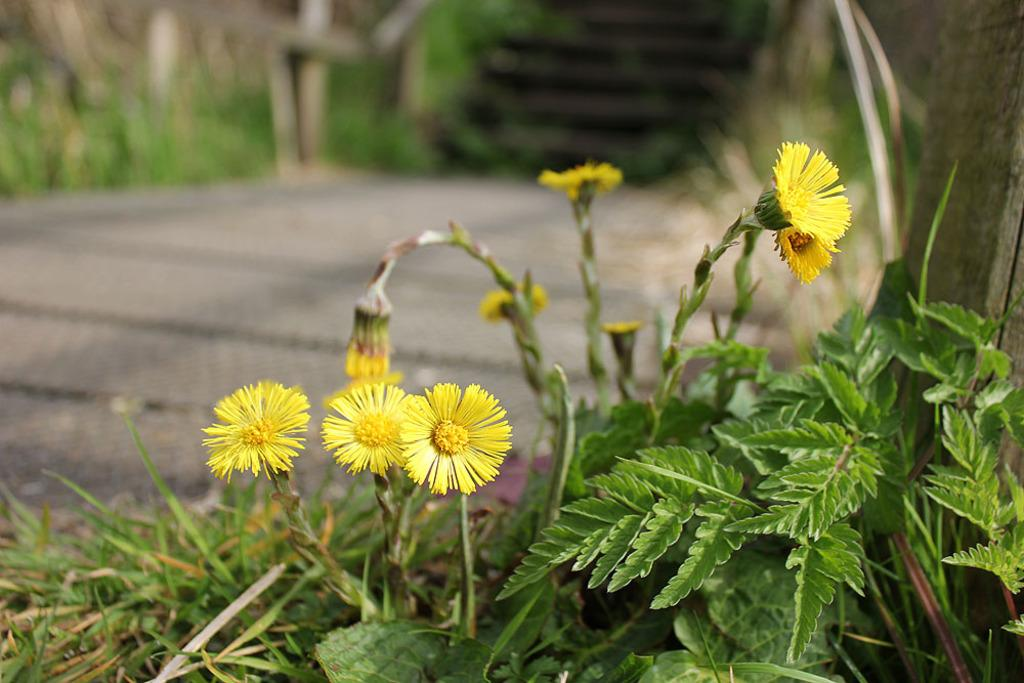What type of plants can be seen in the image? There are flowers and leaves in the image. Can you describe the background of the image? The background of the image is blurry. What type of brass instrument is being played in the image? There is no brass instrument present in the image; it features flowers and leaves with a blurry background. 